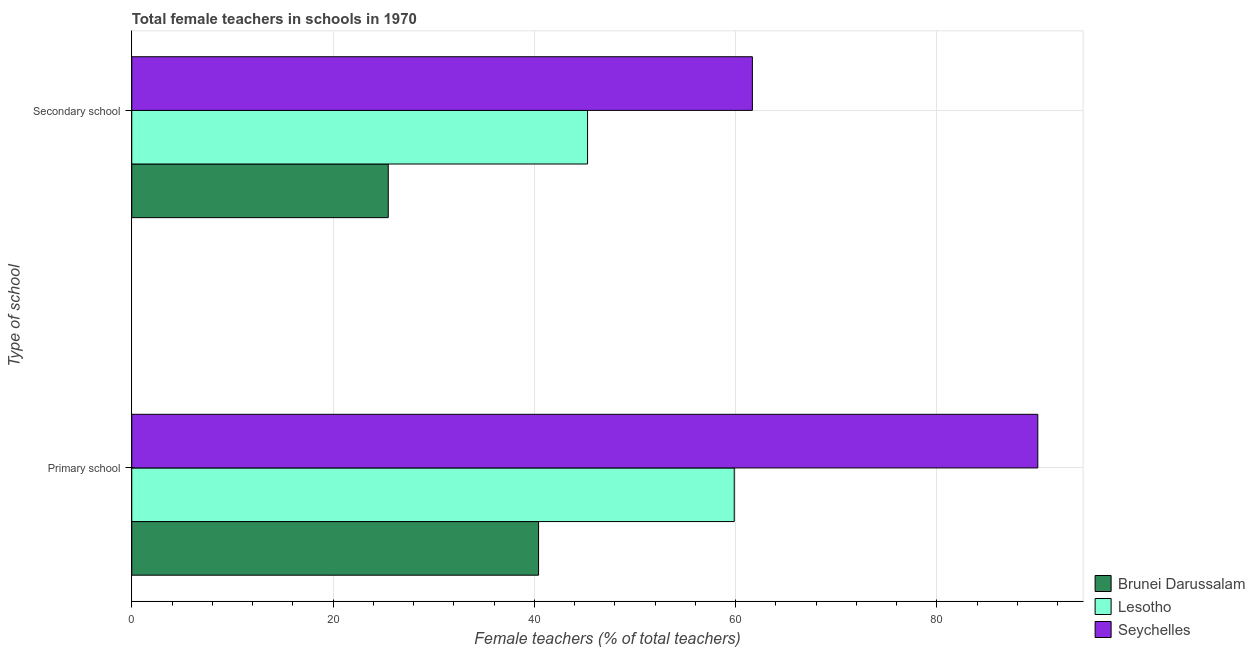Are the number of bars per tick equal to the number of legend labels?
Give a very brief answer. Yes. Are the number of bars on each tick of the Y-axis equal?
Give a very brief answer. Yes. What is the label of the 2nd group of bars from the top?
Ensure brevity in your answer.  Primary school. What is the percentage of female teachers in secondary schools in Seychelles?
Your answer should be compact. 61.67. Across all countries, what is the maximum percentage of female teachers in secondary schools?
Your answer should be very brief. 61.67. Across all countries, what is the minimum percentage of female teachers in primary schools?
Offer a terse response. 40.42. In which country was the percentage of female teachers in secondary schools maximum?
Ensure brevity in your answer.  Seychelles. In which country was the percentage of female teachers in primary schools minimum?
Your answer should be compact. Brunei Darussalam. What is the total percentage of female teachers in secondary schools in the graph?
Keep it short and to the point. 132.44. What is the difference between the percentage of female teachers in primary schools in Lesotho and that in Brunei Darussalam?
Your response must be concise. 19.44. What is the difference between the percentage of female teachers in primary schools in Brunei Darussalam and the percentage of female teachers in secondary schools in Seychelles?
Your answer should be very brief. -21.25. What is the average percentage of female teachers in secondary schools per country?
Your answer should be very brief. 44.15. What is the difference between the percentage of female teachers in secondary schools and percentage of female teachers in primary schools in Lesotho?
Provide a succinct answer. -14.58. In how many countries, is the percentage of female teachers in secondary schools greater than 16 %?
Make the answer very short. 3. What is the ratio of the percentage of female teachers in secondary schools in Lesotho to that in Brunei Darussalam?
Provide a succinct answer. 1.78. In how many countries, is the percentage of female teachers in primary schools greater than the average percentage of female teachers in primary schools taken over all countries?
Offer a terse response. 1. What does the 1st bar from the top in Secondary school represents?
Provide a succinct answer. Seychelles. What does the 1st bar from the bottom in Secondary school represents?
Provide a short and direct response. Brunei Darussalam. How many bars are there?
Ensure brevity in your answer.  6. Are all the bars in the graph horizontal?
Offer a terse response. Yes. How many countries are there in the graph?
Your response must be concise. 3. Are the values on the major ticks of X-axis written in scientific E-notation?
Make the answer very short. No. Does the graph contain grids?
Your answer should be compact. Yes. Where does the legend appear in the graph?
Your answer should be very brief. Bottom right. What is the title of the graph?
Give a very brief answer. Total female teachers in schools in 1970. What is the label or title of the X-axis?
Your response must be concise. Female teachers (% of total teachers). What is the label or title of the Y-axis?
Your answer should be compact. Type of school. What is the Female teachers (% of total teachers) in Brunei Darussalam in Primary school?
Keep it short and to the point. 40.42. What is the Female teachers (% of total teachers) of Lesotho in Primary school?
Your answer should be compact. 59.86. What is the Female teachers (% of total teachers) in Seychelles in Primary school?
Offer a very short reply. 90.03. What is the Female teachers (% of total teachers) in Brunei Darussalam in Secondary school?
Your response must be concise. 25.49. What is the Female teachers (% of total teachers) of Lesotho in Secondary school?
Your answer should be very brief. 45.29. What is the Female teachers (% of total teachers) of Seychelles in Secondary school?
Give a very brief answer. 61.67. Across all Type of school, what is the maximum Female teachers (% of total teachers) of Brunei Darussalam?
Give a very brief answer. 40.42. Across all Type of school, what is the maximum Female teachers (% of total teachers) of Lesotho?
Your answer should be compact. 59.86. Across all Type of school, what is the maximum Female teachers (% of total teachers) of Seychelles?
Your answer should be compact. 90.03. Across all Type of school, what is the minimum Female teachers (% of total teachers) of Brunei Darussalam?
Your answer should be very brief. 25.49. Across all Type of school, what is the minimum Female teachers (% of total teachers) in Lesotho?
Make the answer very short. 45.29. Across all Type of school, what is the minimum Female teachers (% of total teachers) in Seychelles?
Your answer should be compact. 61.67. What is the total Female teachers (% of total teachers) in Brunei Darussalam in the graph?
Offer a terse response. 65.91. What is the total Female teachers (% of total teachers) of Lesotho in the graph?
Your response must be concise. 105.15. What is the total Female teachers (% of total teachers) of Seychelles in the graph?
Ensure brevity in your answer.  151.69. What is the difference between the Female teachers (% of total teachers) of Brunei Darussalam in Primary school and that in Secondary school?
Your answer should be compact. 14.93. What is the difference between the Female teachers (% of total teachers) in Lesotho in Primary school and that in Secondary school?
Provide a succinct answer. 14.57. What is the difference between the Female teachers (% of total teachers) of Seychelles in Primary school and that in Secondary school?
Provide a short and direct response. 28.36. What is the difference between the Female teachers (% of total teachers) of Brunei Darussalam in Primary school and the Female teachers (% of total teachers) of Lesotho in Secondary school?
Your response must be concise. -4.87. What is the difference between the Female teachers (% of total teachers) in Brunei Darussalam in Primary school and the Female teachers (% of total teachers) in Seychelles in Secondary school?
Keep it short and to the point. -21.25. What is the difference between the Female teachers (% of total teachers) of Lesotho in Primary school and the Female teachers (% of total teachers) of Seychelles in Secondary school?
Make the answer very short. -1.8. What is the average Female teachers (% of total teachers) of Brunei Darussalam per Type of school?
Give a very brief answer. 32.95. What is the average Female teachers (% of total teachers) in Lesotho per Type of school?
Your answer should be very brief. 52.58. What is the average Female teachers (% of total teachers) in Seychelles per Type of school?
Your answer should be very brief. 75.85. What is the difference between the Female teachers (% of total teachers) of Brunei Darussalam and Female teachers (% of total teachers) of Lesotho in Primary school?
Your answer should be very brief. -19.44. What is the difference between the Female teachers (% of total teachers) of Brunei Darussalam and Female teachers (% of total teachers) of Seychelles in Primary school?
Make the answer very short. -49.61. What is the difference between the Female teachers (% of total teachers) in Lesotho and Female teachers (% of total teachers) in Seychelles in Primary school?
Offer a very short reply. -30.16. What is the difference between the Female teachers (% of total teachers) of Brunei Darussalam and Female teachers (% of total teachers) of Lesotho in Secondary school?
Offer a very short reply. -19.8. What is the difference between the Female teachers (% of total teachers) of Brunei Darussalam and Female teachers (% of total teachers) of Seychelles in Secondary school?
Ensure brevity in your answer.  -36.18. What is the difference between the Female teachers (% of total teachers) of Lesotho and Female teachers (% of total teachers) of Seychelles in Secondary school?
Offer a very short reply. -16.38. What is the ratio of the Female teachers (% of total teachers) of Brunei Darussalam in Primary school to that in Secondary school?
Ensure brevity in your answer.  1.59. What is the ratio of the Female teachers (% of total teachers) of Lesotho in Primary school to that in Secondary school?
Offer a terse response. 1.32. What is the ratio of the Female teachers (% of total teachers) of Seychelles in Primary school to that in Secondary school?
Offer a very short reply. 1.46. What is the difference between the highest and the second highest Female teachers (% of total teachers) in Brunei Darussalam?
Keep it short and to the point. 14.93. What is the difference between the highest and the second highest Female teachers (% of total teachers) in Lesotho?
Make the answer very short. 14.57. What is the difference between the highest and the second highest Female teachers (% of total teachers) of Seychelles?
Ensure brevity in your answer.  28.36. What is the difference between the highest and the lowest Female teachers (% of total teachers) in Brunei Darussalam?
Make the answer very short. 14.93. What is the difference between the highest and the lowest Female teachers (% of total teachers) in Lesotho?
Your response must be concise. 14.57. What is the difference between the highest and the lowest Female teachers (% of total teachers) of Seychelles?
Offer a terse response. 28.36. 